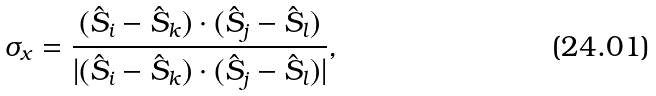Convert formula to latex. <formula><loc_0><loc_0><loc_500><loc_500>\sigma _ { x } = \frac { ( \hat { S } _ { i } - \hat { S } _ { k } ) \cdot ( \hat { S } _ { j } - \hat { S } _ { l } ) } { | ( \hat { S } _ { i } - \hat { S } _ { k } ) \cdot ( \hat { S } _ { j } - \hat { S } _ { l } ) | } ,</formula> 